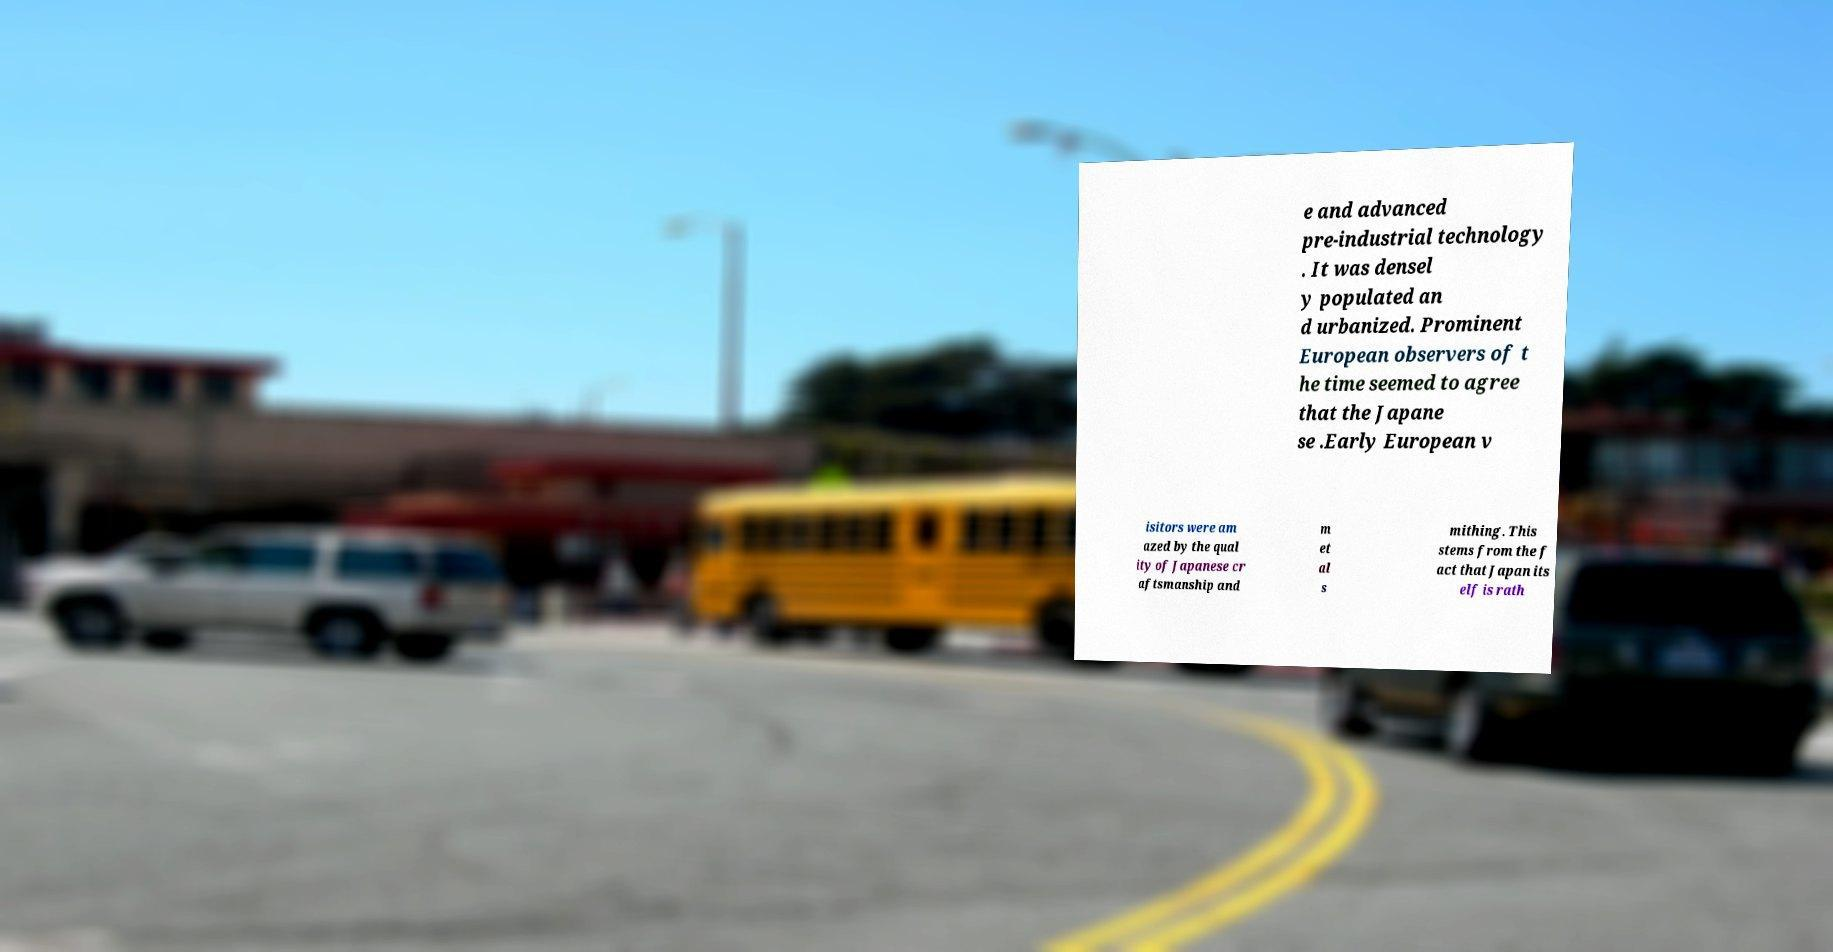Can you accurately transcribe the text from the provided image for me? e and advanced pre-industrial technology . It was densel y populated an d urbanized. Prominent European observers of t he time seemed to agree that the Japane se .Early European v isitors were am azed by the qual ity of Japanese cr aftsmanship and m et al s mithing. This stems from the f act that Japan its elf is rath 